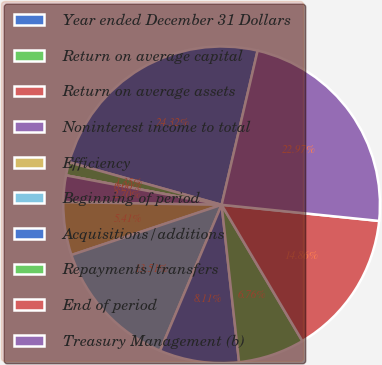<chart> <loc_0><loc_0><loc_500><loc_500><pie_chart><fcel>Year ended December 31 Dollars<fcel>Return on average capital<fcel>Return on average assets<fcel>Noninterest income to total<fcel>Efficiency<fcel>Beginning of period<fcel>Acquisitions/additions<fcel>Repayments/transfers<fcel>End of period<fcel>Treasury Management (b)<nl><fcel>24.32%<fcel>1.35%<fcel>0.0%<fcel>2.7%<fcel>5.41%<fcel>13.51%<fcel>8.11%<fcel>6.76%<fcel>14.86%<fcel>22.97%<nl></chart> 